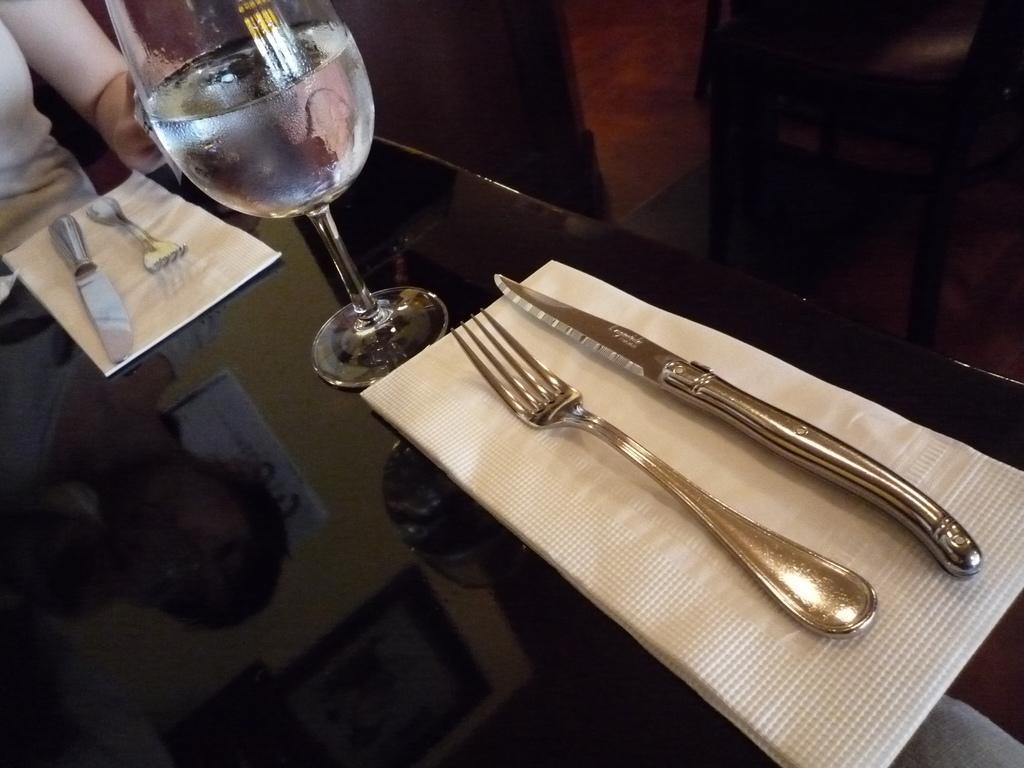Can you describe this image briefly? In the image there is a table and on the table there is a glass, forks and knives. A person is sitting in front of the table. 